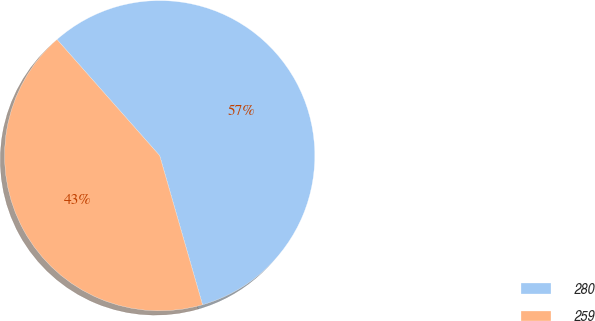<chart> <loc_0><loc_0><loc_500><loc_500><pie_chart><fcel>280<fcel>259<nl><fcel>57.07%<fcel>42.93%<nl></chart> 